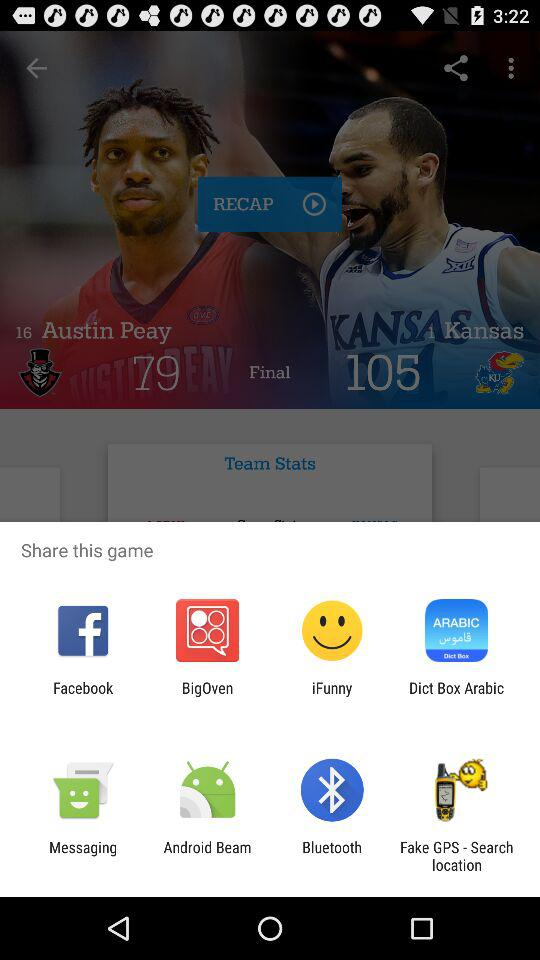What is the final score of "Austin Peay"? The final score is 79. 